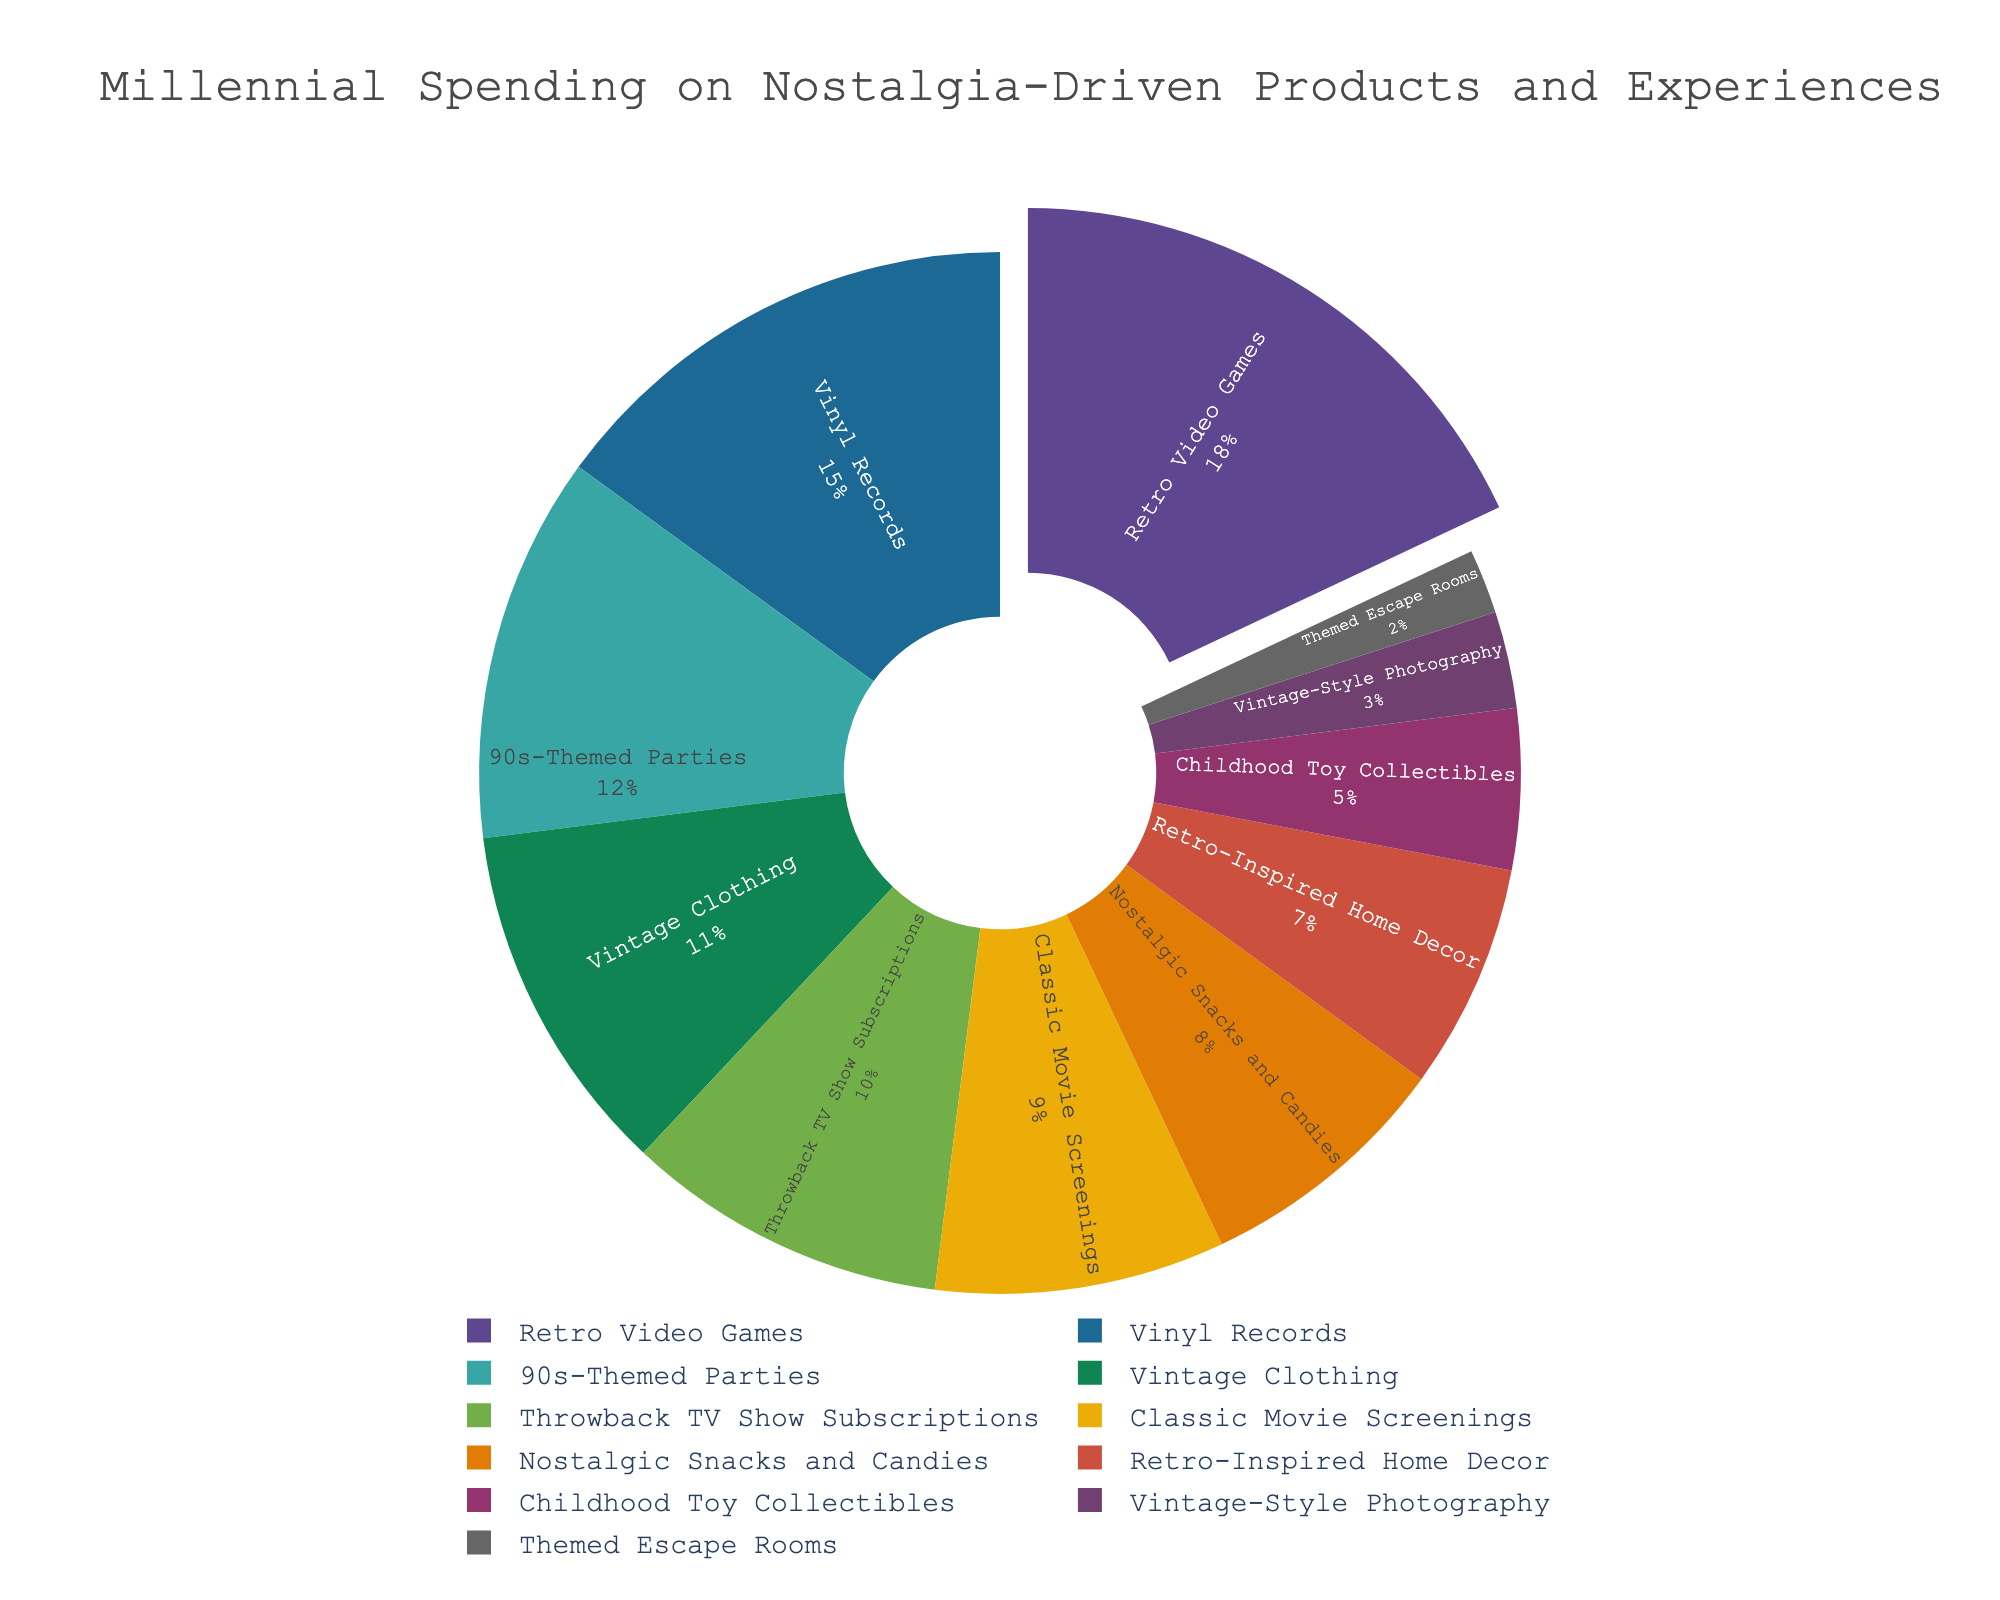What's the largest category of millennial spending on nostalgia-driven products and experiences? The pie chart shows the largest segment clearly, which is Retro Video Games with 18%. You can tell because its section is the biggest visually.
Answer: Retro Video Games Which categories together make up exactly half of the total spending? By summing up the percentages of the categories, Retro Video Games (18%), Vinyl Records (15%), 90s-Themed Parties (12%), you get 18 + 15 + 12 = 45%. Including Vintage Clothing (11%) reaches 45 + 11 = 56%, which crosses half. Therefore, consider fewer categories; Retro Video Games and Vinyl Records is 18 + 15 = 33, adding 90s-Themed Parties makes it 33 + 12 = 45, still less. Adding Vintage Clothing reaches 56. No category sums exactly 50%, but closely 90s-Themed Parties, Vinyl Records, and Retro Video Games total 45%.
Answer: No exact half, but closest is 45% from Retro Video Games, Vinyl Records, and 90s-Themed Parties What's the combined percentage of spending on Classic Movie Screenings and Nostalgic Snacks and Candies? Sum the percentages from both categories: 9% (Classic Movie Screenings) + 8% (Nostalgic Snacks and Candies) = 17%
Answer: 17% Which category has the smallest spending percentage? The smallest segment on the pie chart represents Themed Escape Rooms with a percentage of 2%.
Answer: Themed Escape Rooms How much more is spent on Retro Video Games compared to Childhood Toy Collectibles? Subtract the percentage of Childhood Toy Collectibles (5%) from Retro Video Games (18%): 18% - 5% = 13%
Answer: 13% How does the spending on Vintage-Style Photography compare to Throwback TV Show Subscriptions? Compare the percentages: Vintage-Style Photography is 3%, and Throwback TV Show Subscriptions is 10%. 3% is significantly lower than 10%.
Answer: Lower What is the total percentage of spending on experiences (90s-Themed Parties, Classic Movie Screenings, and Themed Escape Rooms)? Sum the percentages of 90s-Themed Parties (12%), Classic Movie Screenings (9%), and Themed Escape Rooms (2%): 12% + 9% + 2% = 23%
Answer: 23% Which is greater: the total spending on Retro-Inspired Home Decor, and Childhood Toy Collectibles combined, or the spending on Vinyl Records alone? Sum the percentages of Retro-Inspired Home Decor (7%) and Childhood Toy Collectibles (5%): 7% + 5% = 12%. Compare with Vinyl Records, which is 15%. Vinyl Records has a greater percentage.
Answer: Vinyl Records 